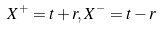Convert formula to latex. <formula><loc_0><loc_0><loc_500><loc_500>X ^ { + } = t + r , X ^ { - } = t - r</formula> 